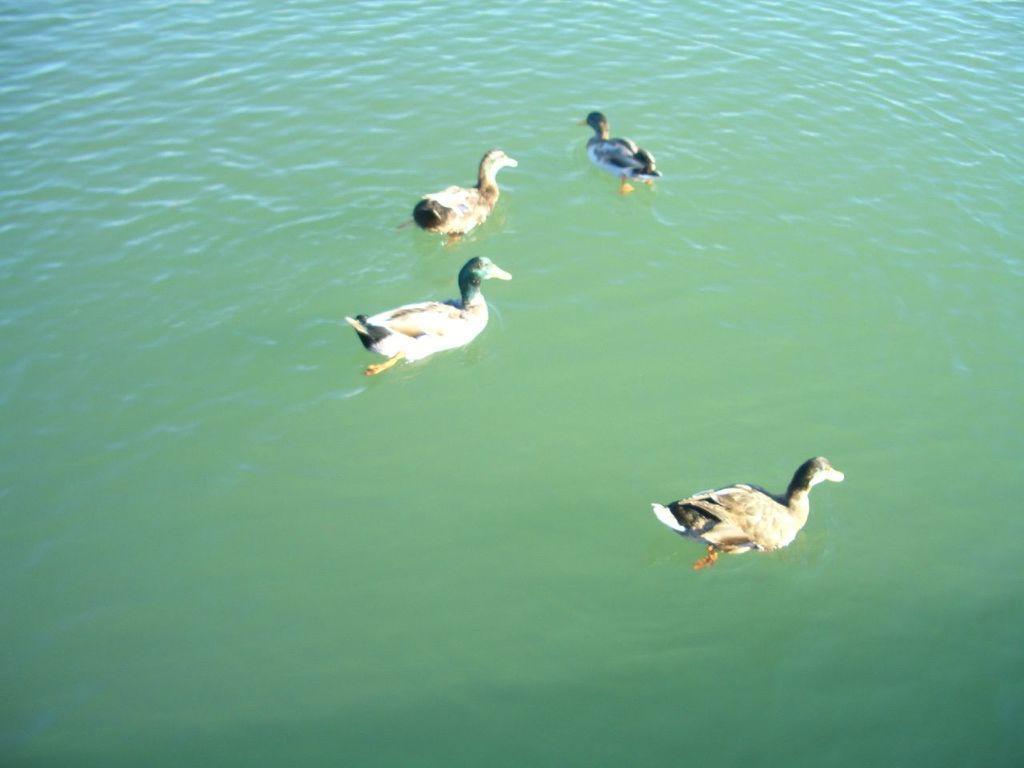Could you give a brief overview of what you see in this image? In this picture, we can see a few birds on water. 